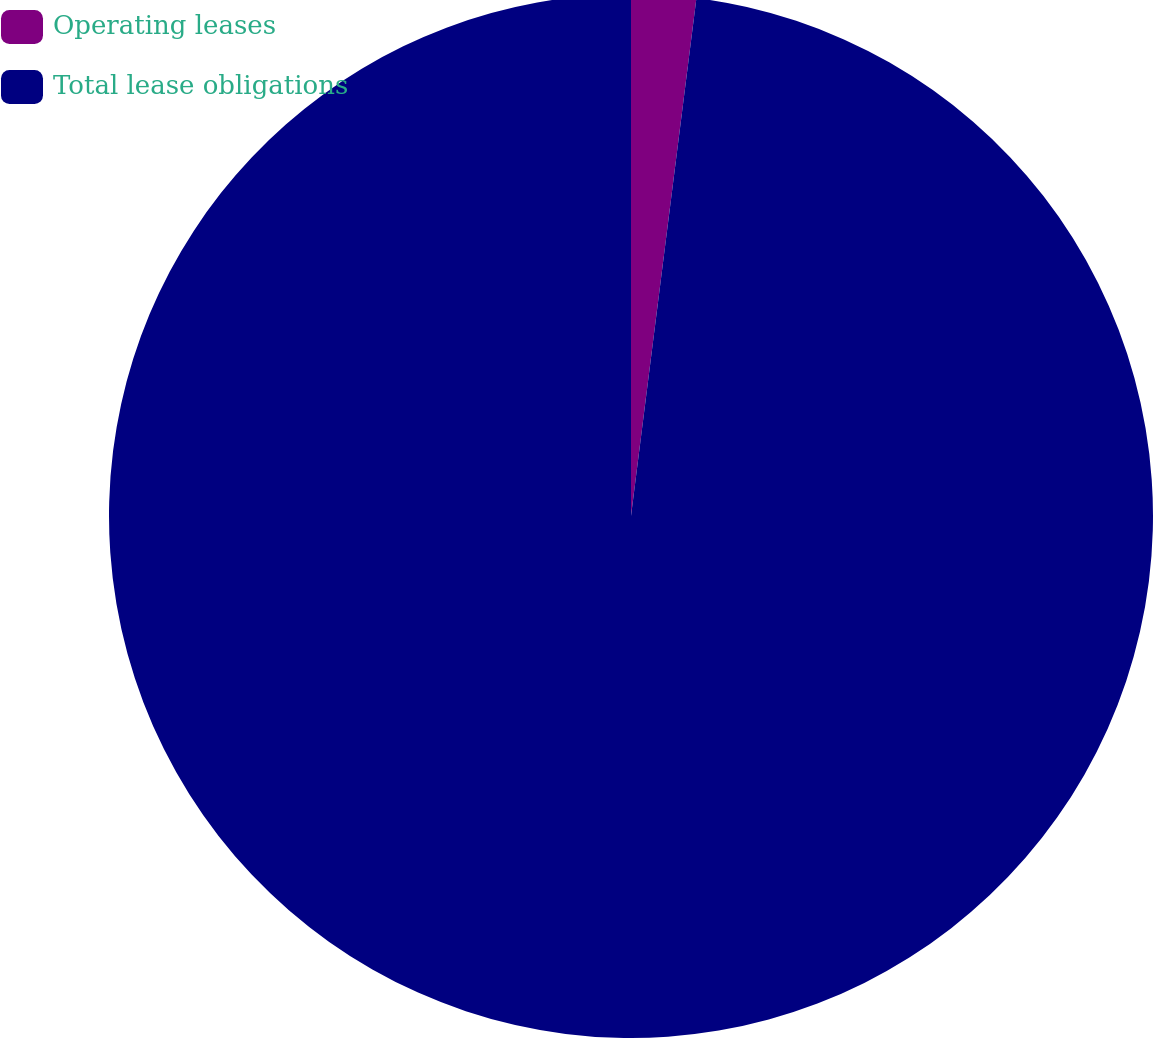Convert chart. <chart><loc_0><loc_0><loc_500><loc_500><pie_chart><fcel>Operating leases<fcel>Total lease obligations<nl><fcel>2.0%<fcel>98.0%<nl></chart> 